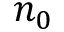<formula> <loc_0><loc_0><loc_500><loc_500>n _ { 0 }</formula> 